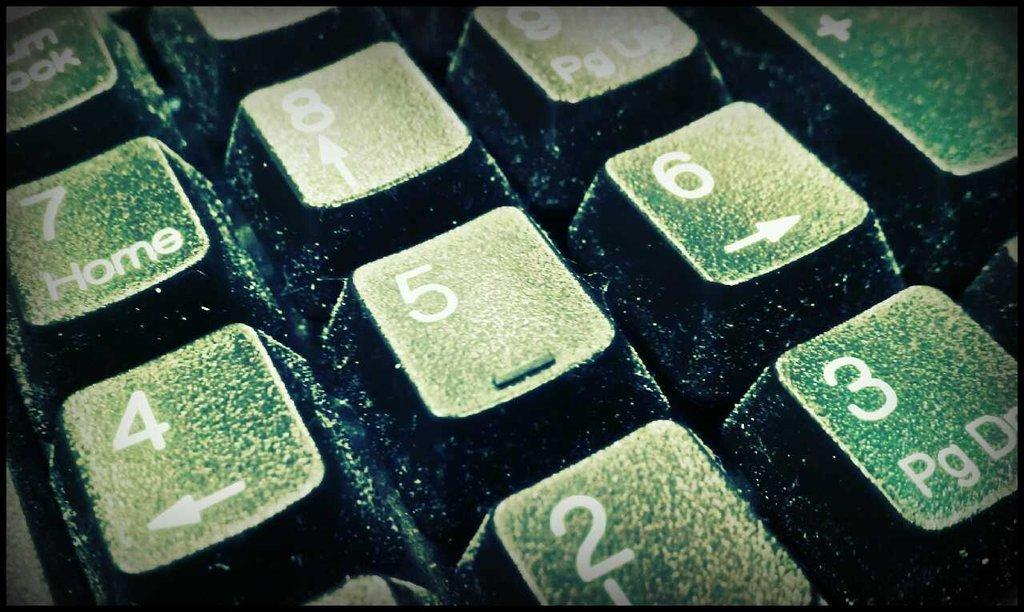<image>
Share a concise interpretation of the image provided. a close up of a green key pad with keys for Home and 5 